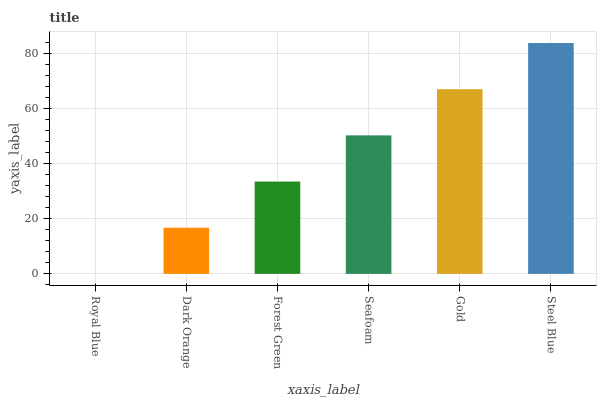Is Royal Blue the minimum?
Answer yes or no. Yes. Is Steel Blue the maximum?
Answer yes or no. Yes. Is Dark Orange the minimum?
Answer yes or no. No. Is Dark Orange the maximum?
Answer yes or no. No. Is Dark Orange greater than Royal Blue?
Answer yes or no. Yes. Is Royal Blue less than Dark Orange?
Answer yes or no. Yes. Is Royal Blue greater than Dark Orange?
Answer yes or no. No. Is Dark Orange less than Royal Blue?
Answer yes or no. No. Is Seafoam the high median?
Answer yes or no. Yes. Is Forest Green the low median?
Answer yes or no. Yes. Is Steel Blue the high median?
Answer yes or no. No. Is Gold the low median?
Answer yes or no. No. 